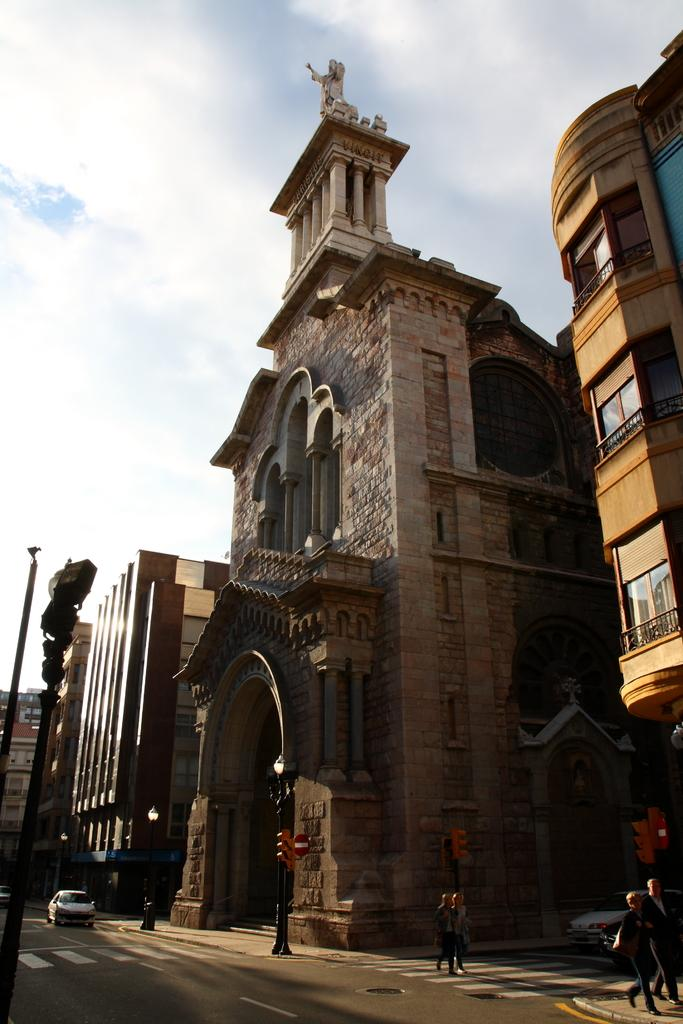What type of structures can be seen in the image? There are buildings in the image. What feature can be observed on the buildings? There are windows visible in the image. What safety feature is present in the image? There is a railing in the image. What type of street furniture is present in the image? There are light-poles in the image. What mode of transportation can be seen in the image? There are vehicles in the image. What activity are people engaged in within the image? There are people walking on the road in the image. What is the color of the sky in the image? The sky is blue and white in color. Can you hear the waves crashing in the image? There are no waves present in the image, as it features an urban scene with buildings, vehicles, and people walking on the road. What type of coach is visible in the image? There is no coach present in the image. 